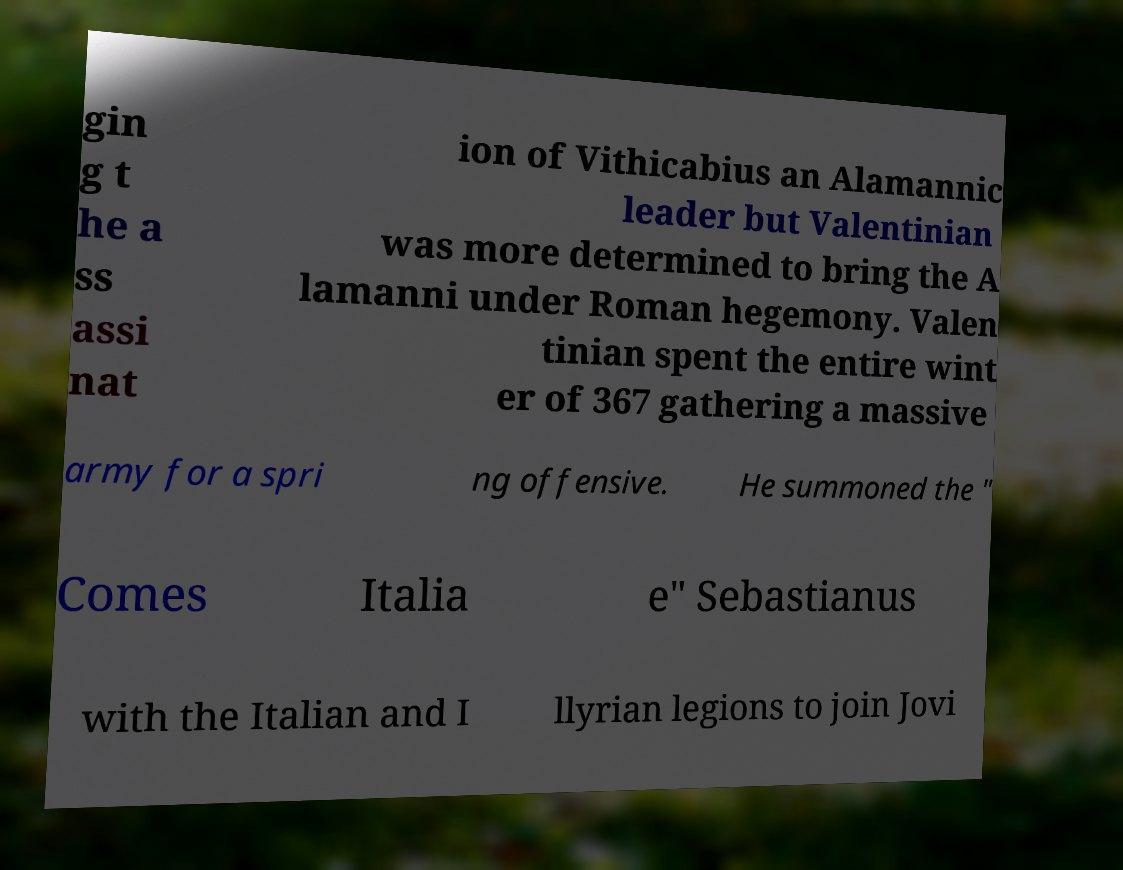Could you extract and type out the text from this image? gin g t he a ss assi nat ion of Vithicabius an Alamannic leader but Valentinian was more determined to bring the A lamanni under Roman hegemony. Valen tinian spent the entire wint er of 367 gathering a massive army for a spri ng offensive. He summoned the " Comes Italia e" Sebastianus with the Italian and I llyrian legions to join Jovi 